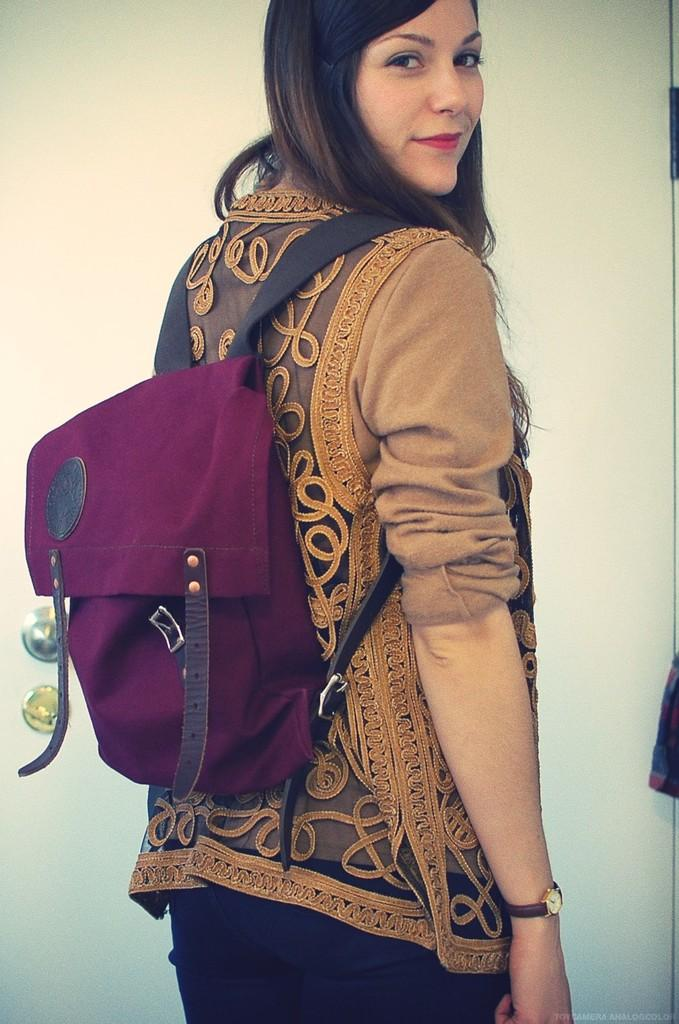Who is present in the image? There is a lady in the image. What accessory is the lady wearing on her wrist? The lady is wearing a watch. What type of item is the lady carrying on her shoulder or arm? The lady is wearing a bag. What can be seen in the background of the image? There is a door visible in the background of the image. What is the name of the lady's father in the image? There is no information about the lady's father in the image, so we cannot determine his name. 